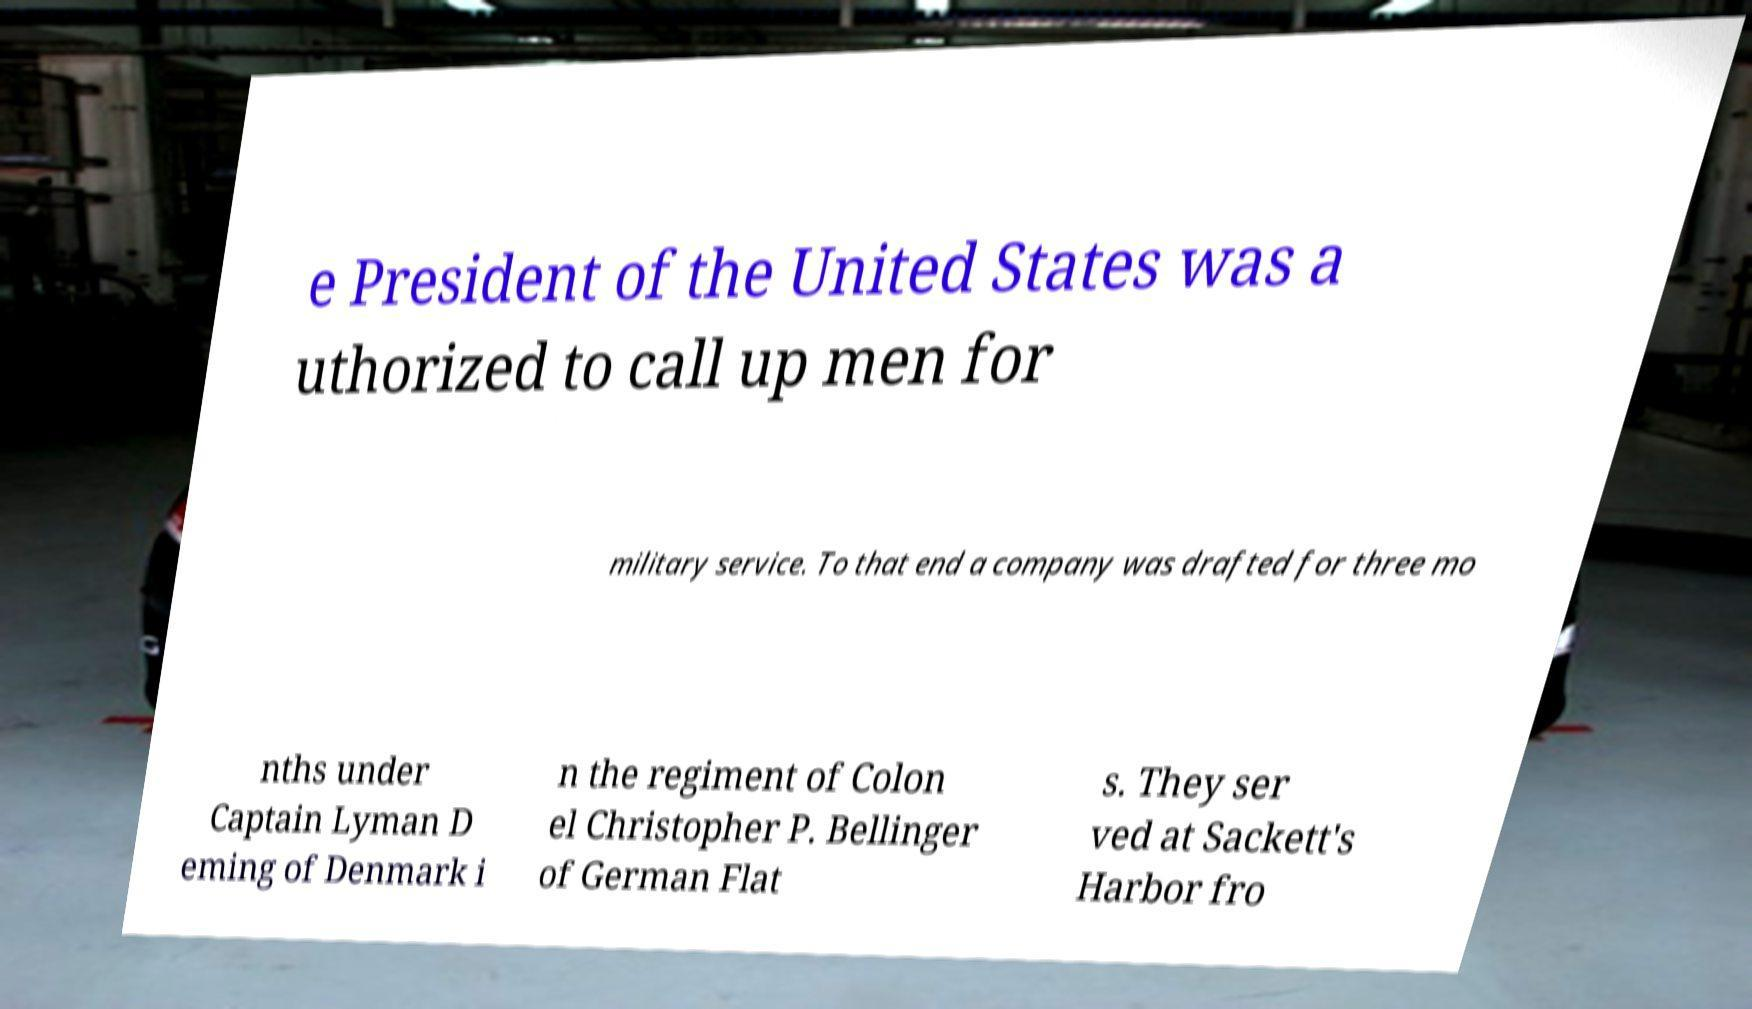There's text embedded in this image that I need extracted. Can you transcribe it verbatim? e President of the United States was a uthorized to call up men for military service. To that end a company was drafted for three mo nths under Captain Lyman D eming of Denmark i n the regiment of Colon el Christopher P. Bellinger of German Flat s. They ser ved at Sackett's Harbor fro 